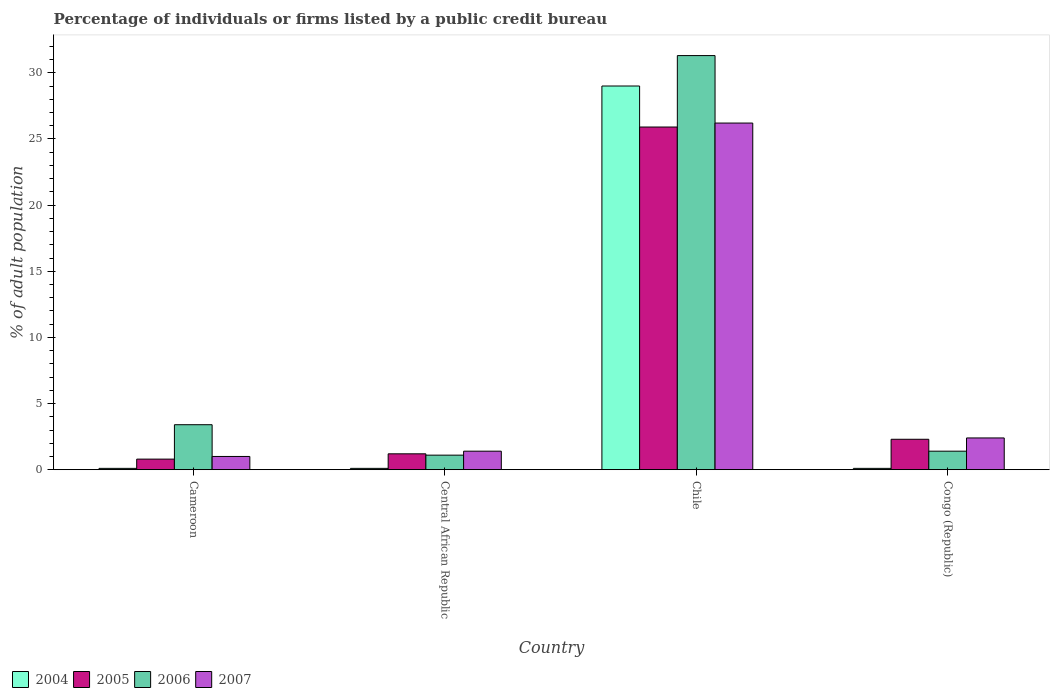How many different coloured bars are there?
Keep it short and to the point. 4. Are the number of bars per tick equal to the number of legend labels?
Provide a short and direct response. Yes. Are the number of bars on each tick of the X-axis equal?
Offer a very short reply. Yes. What is the label of the 2nd group of bars from the left?
Your answer should be compact. Central African Republic. In how many cases, is the number of bars for a given country not equal to the number of legend labels?
Ensure brevity in your answer.  0. Across all countries, what is the maximum percentage of population listed by a public credit bureau in 2007?
Provide a short and direct response. 26.2. In which country was the percentage of population listed by a public credit bureau in 2007 minimum?
Your response must be concise. Cameroon. What is the total percentage of population listed by a public credit bureau in 2007 in the graph?
Ensure brevity in your answer.  31. What is the difference between the percentage of population listed by a public credit bureau in 2004 in Cameroon and that in Chile?
Provide a short and direct response. -28.9. What is the difference between the percentage of population listed by a public credit bureau in 2005 in Chile and the percentage of population listed by a public credit bureau in 2004 in Congo (Republic)?
Your answer should be very brief. 25.8. What is the average percentage of population listed by a public credit bureau in 2006 per country?
Give a very brief answer. 9.3. What is the difference between the percentage of population listed by a public credit bureau of/in 2007 and percentage of population listed by a public credit bureau of/in 2005 in Congo (Republic)?
Offer a terse response. 0.1. In how many countries, is the percentage of population listed by a public credit bureau in 2004 greater than 29 %?
Offer a terse response. 0. What is the ratio of the percentage of population listed by a public credit bureau in 2007 in Chile to that in Congo (Republic)?
Your response must be concise. 10.92. Is the percentage of population listed by a public credit bureau in 2007 in Cameroon less than that in Congo (Republic)?
Offer a terse response. Yes. Is the difference between the percentage of population listed by a public credit bureau in 2007 in Cameroon and Chile greater than the difference between the percentage of population listed by a public credit bureau in 2005 in Cameroon and Chile?
Provide a short and direct response. No. What is the difference between the highest and the second highest percentage of population listed by a public credit bureau in 2006?
Your response must be concise. -2. What is the difference between the highest and the lowest percentage of population listed by a public credit bureau in 2005?
Your answer should be compact. 25.1. In how many countries, is the percentage of population listed by a public credit bureau in 2006 greater than the average percentage of population listed by a public credit bureau in 2006 taken over all countries?
Give a very brief answer. 1. Is the sum of the percentage of population listed by a public credit bureau in 2004 in Chile and Congo (Republic) greater than the maximum percentage of population listed by a public credit bureau in 2005 across all countries?
Your answer should be very brief. Yes. What does the 2nd bar from the left in Cameroon represents?
Your response must be concise. 2005. Are all the bars in the graph horizontal?
Make the answer very short. No. Are the values on the major ticks of Y-axis written in scientific E-notation?
Offer a terse response. No. Does the graph contain any zero values?
Offer a terse response. No. Does the graph contain grids?
Provide a short and direct response. No. What is the title of the graph?
Provide a short and direct response. Percentage of individuals or firms listed by a public credit bureau. Does "1960" appear as one of the legend labels in the graph?
Offer a very short reply. No. What is the label or title of the Y-axis?
Provide a succinct answer. % of adult population. What is the % of adult population of 2004 in Cameroon?
Keep it short and to the point. 0.1. What is the % of adult population in 2007 in Cameroon?
Ensure brevity in your answer.  1. What is the % of adult population of 2006 in Central African Republic?
Your response must be concise. 1.1. What is the % of adult population in 2007 in Central African Republic?
Keep it short and to the point. 1.4. What is the % of adult population of 2005 in Chile?
Keep it short and to the point. 25.9. What is the % of adult population of 2006 in Chile?
Offer a terse response. 31.3. What is the % of adult population in 2007 in Chile?
Provide a succinct answer. 26.2. What is the % of adult population of 2004 in Congo (Republic)?
Your answer should be compact. 0.1. What is the % of adult population of 2007 in Congo (Republic)?
Your response must be concise. 2.4. Across all countries, what is the maximum % of adult population of 2004?
Offer a very short reply. 29. Across all countries, what is the maximum % of adult population of 2005?
Ensure brevity in your answer.  25.9. Across all countries, what is the maximum % of adult population in 2006?
Your answer should be very brief. 31.3. Across all countries, what is the maximum % of adult population in 2007?
Your answer should be very brief. 26.2. Across all countries, what is the minimum % of adult population of 2004?
Offer a very short reply. 0.1. What is the total % of adult population in 2004 in the graph?
Ensure brevity in your answer.  29.3. What is the total % of adult population in 2005 in the graph?
Give a very brief answer. 30.2. What is the total % of adult population in 2006 in the graph?
Your answer should be very brief. 37.2. What is the total % of adult population of 2007 in the graph?
Keep it short and to the point. 31. What is the difference between the % of adult population in 2004 in Cameroon and that in Central African Republic?
Your answer should be very brief. 0. What is the difference between the % of adult population in 2004 in Cameroon and that in Chile?
Keep it short and to the point. -28.9. What is the difference between the % of adult population in 2005 in Cameroon and that in Chile?
Offer a terse response. -25.1. What is the difference between the % of adult population in 2006 in Cameroon and that in Chile?
Make the answer very short. -27.9. What is the difference between the % of adult population in 2007 in Cameroon and that in Chile?
Make the answer very short. -25.2. What is the difference between the % of adult population in 2004 in Cameroon and that in Congo (Republic)?
Ensure brevity in your answer.  0. What is the difference between the % of adult population of 2005 in Cameroon and that in Congo (Republic)?
Your answer should be compact. -1.5. What is the difference between the % of adult population of 2006 in Cameroon and that in Congo (Republic)?
Your response must be concise. 2. What is the difference between the % of adult population in 2004 in Central African Republic and that in Chile?
Provide a short and direct response. -28.9. What is the difference between the % of adult population in 2005 in Central African Republic and that in Chile?
Ensure brevity in your answer.  -24.7. What is the difference between the % of adult population in 2006 in Central African Republic and that in Chile?
Your response must be concise. -30.2. What is the difference between the % of adult population in 2007 in Central African Republic and that in Chile?
Your answer should be very brief. -24.8. What is the difference between the % of adult population in 2006 in Central African Republic and that in Congo (Republic)?
Your answer should be very brief. -0.3. What is the difference between the % of adult population in 2004 in Chile and that in Congo (Republic)?
Provide a short and direct response. 28.9. What is the difference between the % of adult population in 2005 in Chile and that in Congo (Republic)?
Ensure brevity in your answer.  23.6. What is the difference between the % of adult population in 2006 in Chile and that in Congo (Republic)?
Keep it short and to the point. 29.9. What is the difference between the % of adult population of 2007 in Chile and that in Congo (Republic)?
Your answer should be very brief. 23.8. What is the difference between the % of adult population in 2004 in Cameroon and the % of adult population in 2005 in Central African Republic?
Give a very brief answer. -1.1. What is the difference between the % of adult population of 2005 in Cameroon and the % of adult population of 2007 in Central African Republic?
Give a very brief answer. -0.6. What is the difference between the % of adult population of 2006 in Cameroon and the % of adult population of 2007 in Central African Republic?
Your response must be concise. 2. What is the difference between the % of adult population of 2004 in Cameroon and the % of adult population of 2005 in Chile?
Provide a succinct answer. -25.8. What is the difference between the % of adult population of 2004 in Cameroon and the % of adult population of 2006 in Chile?
Offer a terse response. -31.2. What is the difference between the % of adult population of 2004 in Cameroon and the % of adult population of 2007 in Chile?
Ensure brevity in your answer.  -26.1. What is the difference between the % of adult population of 2005 in Cameroon and the % of adult population of 2006 in Chile?
Offer a very short reply. -30.5. What is the difference between the % of adult population in 2005 in Cameroon and the % of adult population in 2007 in Chile?
Provide a succinct answer. -25.4. What is the difference between the % of adult population of 2006 in Cameroon and the % of adult population of 2007 in Chile?
Offer a terse response. -22.8. What is the difference between the % of adult population in 2004 in Cameroon and the % of adult population in 2006 in Congo (Republic)?
Give a very brief answer. -1.3. What is the difference between the % of adult population of 2004 in Cameroon and the % of adult population of 2007 in Congo (Republic)?
Make the answer very short. -2.3. What is the difference between the % of adult population in 2005 in Cameroon and the % of adult population in 2007 in Congo (Republic)?
Give a very brief answer. -1.6. What is the difference between the % of adult population in 2006 in Cameroon and the % of adult population in 2007 in Congo (Republic)?
Offer a terse response. 1. What is the difference between the % of adult population of 2004 in Central African Republic and the % of adult population of 2005 in Chile?
Keep it short and to the point. -25.8. What is the difference between the % of adult population of 2004 in Central African Republic and the % of adult population of 2006 in Chile?
Your answer should be very brief. -31.2. What is the difference between the % of adult population of 2004 in Central African Republic and the % of adult population of 2007 in Chile?
Your response must be concise. -26.1. What is the difference between the % of adult population of 2005 in Central African Republic and the % of adult population of 2006 in Chile?
Your answer should be very brief. -30.1. What is the difference between the % of adult population of 2005 in Central African Republic and the % of adult population of 2007 in Chile?
Give a very brief answer. -25. What is the difference between the % of adult population in 2006 in Central African Republic and the % of adult population in 2007 in Chile?
Your answer should be very brief. -25.1. What is the difference between the % of adult population in 2004 in Central African Republic and the % of adult population in 2005 in Congo (Republic)?
Give a very brief answer. -2.2. What is the difference between the % of adult population in 2005 in Central African Republic and the % of adult population in 2006 in Congo (Republic)?
Offer a very short reply. -0.2. What is the difference between the % of adult population in 2005 in Central African Republic and the % of adult population in 2007 in Congo (Republic)?
Your answer should be compact. -1.2. What is the difference between the % of adult population in 2004 in Chile and the % of adult population in 2005 in Congo (Republic)?
Ensure brevity in your answer.  26.7. What is the difference between the % of adult population in 2004 in Chile and the % of adult population in 2006 in Congo (Republic)?
Your answer should be compact. 27.6. What is the difference between the % of adult population in 2004 in Chile and the % of adult population in 2007 in Congo (Republic)?
Your response must be concise. 26.6. What is the difference between the % of adult population in 2005 in Chile and the % of adult population in 2006 in Congo (Republic)?
Provide a short and direct response. 24.5. What is the difference between the % of adult population in 2005 in Chile and the % of adult population in 2007 in Congo (Republic)?
Offer a terse response. 23.5. What is the difference between the % of adult population of 2006 in Chile and the % of adult population of 2007 in Congo (Republic)?
Offer a terse response. 28.9. What is the average % of adult population of 2004 per country?
Offer a terse response. 7.33. What is the average % of adult population in 2005 per country?
Provide a short and direct response. 7.55. What is the average % of adult population in 2006 per country?
Offer a very short reply. 9.3. What is the average % of adult population in 2007 per country?
Offer a very short reply. 7.75. What is the difference between the % of adult population of 2004 and % of adult population of 2005 in Cameroon?
Provide a short and direct response. -0.7. What is the difference between the % of adult population in 2004 and % of adult population in 2007 in Cameroon?
Offer a terse response. -0.9. What is the difference between the % of adult population in 2006 and % of adult population in 2007 in Cameroon?
Your response must be concise. 2.4. What is the difference between the % of adult population of 2004 and % of adult population of 2005 in Central African Republic?
Your answer should be very brief. -1.1. What is the difference between the % of adult population of 2004 and % of adult population of 2006 in Central African Republic?
Provide a succinct answer. -1. What is the difference between the % of adult population in 2005 and % of adult population in 2006 in Central African Republic?
Offer a very short reply. 0.1. What is the difference between the % of adult population of 2006 and % of adult population of 2007 in Central African Republic?
Ensure brevity in your answer.  -0.3. What is the difference between the % of adult population of 2004 and % of adult population of 2005 in Chile?
Provide a short and direct response. 3.1. What is the difference between the % of adult population in 2004 and % of adult population in 2006 in Chile?
Your answer should be compact. -2.3. What is the difference between the % of adult population in 2004 and % of adult population in 2007 in Chile?
Give a very brief answer. 2.8. What is the difference between the % of adult population of 2004 and % of adult population of 2005 in Congo (Republic)?
Make the answer very short. -2.2. What is the difference between the % of adult population in 2004 and % of adult population in 2006 in Congo (Republic)?
Your answer should be very brief. -1.3. What is the difference between the % of adult population in 2005 and % of adult population in 2006 in Congo (Republic)?
Keep it short and to the point. 0.9. What is the ratio of the % of adult population of 2006 in Cameroon to that in Central African Republic?
Your answer should be very brief. 3.09. What is the ratio of the % of adult population of 2007 in Cameroon to that in Central African Republic?
Make the answer very short. 0.71. What is the ratio of the % of adult population in 2004 in Cameroon to that in Chile?
Make the answer very short. 0. What is the ratio of the % of adult population in 2005 in Cameroon to that in Chile?
Your response must be concise. 0.03. What is the ratio of the % of adult population in 2006 in Cameroon to that in Chile?
Ensure brevity in your answer.  0.11. What is the ratio of the % of adult population in 2007 in Cameroon to that in Chile?
Provide a succinct answer. 0.04. What is the ratio of the % of adult population in 2004 in Cameroon to that in Congo (Republic)?
Keep it short and to the point. 1. What is the ratio of the % of adult population of 2005 in Cameroon to that in Congo (Republic)?
Provide a succinct answer. 0.35. What is the ratio of the % of adult population of 2006 in Cameroon to that in Congo (Republic)?
Your answer should be compact. 2.43. What is the ratio of the % of adult population in 2007 in Cameroon to that in Congo (Republic)?
Make the answer very short. 0.42. What is the ratio of the % of adult population of 2004 in Central African Republic to that in Chile?
Offer a terse response. 0. What is the ratio of the % of adult population of 2005 in Central African Republic to that in Chile?
Provide a succinct answer. 0.05. What is the ratio of the % of adult population in 2006 in Central African Republic to that in Chile?
Offer a terse response. 0.04. What is the ratio of the % of adult population of 2007 in Central African Republic to that in Chile?
Your answer should be very brief. 0.05. What is the ratio of the % of adult population in 2004 in Central African Republic to that in Congo (Republic)?
Your answer should be compact. 1. What is the ratio of the % of adult population of 2005 in Central African Republic to that in Congo (Republic)?
Your response must be concise. 0.52. What is the ratio of the % of adult population of 2006 in Central African Republic to that in Congo (Republic)?
Make the answer very short. 0.79. What is the ratio of the % of adult population of 2007 in Central African Republic to that in Congo (Republic)?
Your answer should be compact. 0.58. What is the ratio of the % of adult population of 2004 in Chile to that in Congo (Republic)?
Offer a very short reply. 290. What is the ratio of the % of adult population in 2005 in Chile to that in Congo (Republic)?
Your response must be concise. 11.26. What is the ratio of the % of adult population of 2006 in Chile to that in Congo (Republic)?
Provide a short and direct response. 22.36. What is the ratio of the % of adult population in 2007 in Chile to that in Congo (Republic)?
Make the answer very short. 10.92. What is the difference between the highest and the second highest % of adult population of 2004?
Provide a succinct answer. 28.9. What is the difference between the highest and the second highest % of adult population of 2005?
Your answer should be compact. 23.6. What is the difference between the highest and the second highest % of adult population in 2006?
Your answer should be compact. 27.9. What is the difference between the highest and the second highest % of adult population of 2007?
Ensure brevity in your answer.  23.8. What is the difference between the highest and the lowest % of adult population in 2004?
Offer a terse response. 28.9. What is the difference between the highest and the lowest % of adult population in 2005?
Your answer should be compact. 25.1. What is the difference between the highest and the lowest % of adult population of 2006?
Provide a short and direct response. 30.2. What is the difference between the highest and the lowest % of adult population in 2007?
Give a very brief answer. 25.2. 